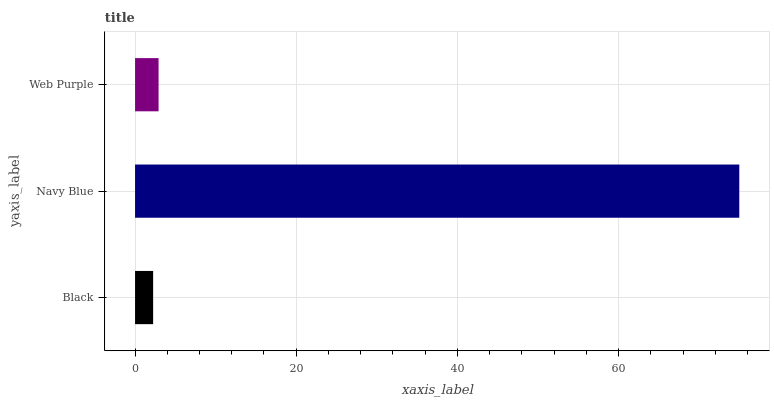Is Black the minimum?
Answer yes or no. Yes. Is Navy Blue the maximum?
Answer yes or no. Yes. Is Web Purple the minimum?
Answer yes or no. No. Is Web Purple the maximum?
Answer yes or no. No. Is Navy Blue greater than Web Purple?
Answer yes or no. Yes. Is Web Purple less than Navy Blue?
Answer yes or no. Yes. Is Web Purple greater than Navy Blue?
Answer yes or no. No. Is Navy Blue less than Web Purple?
Answer yes or no. No. Is Web Purple the high median?
Answer yes or no. Yes. Is Web Purple the low median?
Answer yes or no. Yes. Is Black the high median?
Answer yes or no. No. Is Navy Blue the low median?
Answer yes or no. No. 